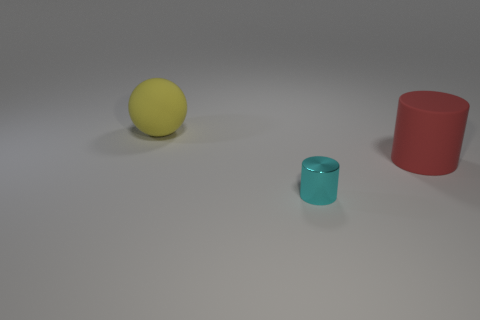What shape is the rubber thing that is behind the cylinder that is behind the small cyan metal object?
Provide a short and direct response. Sphere. How many other objects are there of the same material as the cyan cylinder?
Give a very brief answer. 0. Is there any other thing that is the same size as the red rubber cylinder?
Offer a terse response. Yes. Is the number of big red blocks greater than the number of large matte objects?
Your answer should be very brief. No. There is a rubber object to the right of the cylinder on the left side of the big rubber object on the right side of the yellow rubber ball; what is its size?
Provide a succinct answer. Large. Does the red rubber cylinder have the same size as the rubber thing to the left of the cyan object?
Give a very brief answer. Yes. Are there fewer tiny metal things behind the yellow matte thing than tiny cylinders?
Your answer should be very brief. Yes. What number of large balls have the same color as the metal thing?
Your answer should be compact. 0. Are there fewer big purple metallic spheres than objects?
Offer a terse response. Yes. Do the big cylinder and the large ball have the same material?
Offer a very short reply. Yes. 